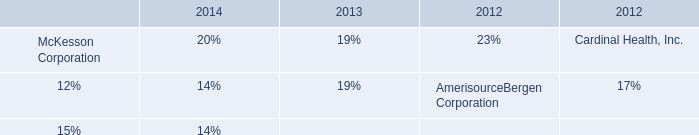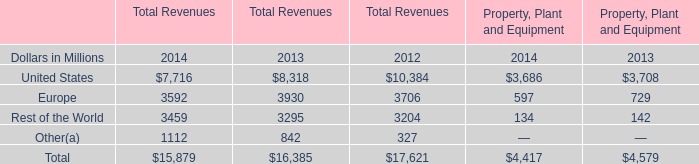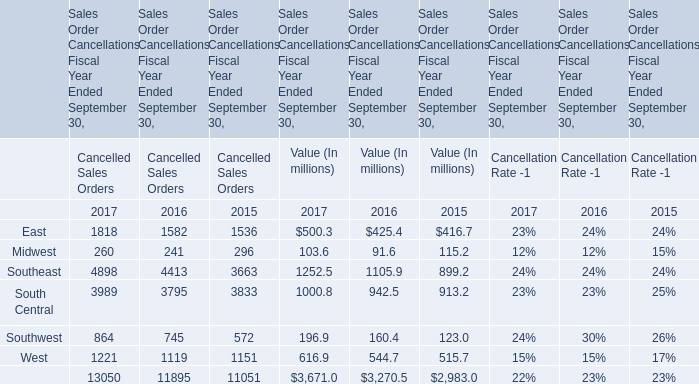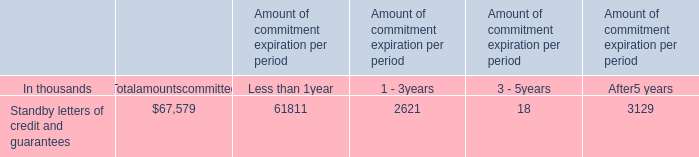In the year / section with lowest amount of Midwest in Value (In millions), what's the increasing rate of East in Value (In millions)? 
Computations: ((425.4 - 416.7) / 416.7)
Answer: 0.02088. 